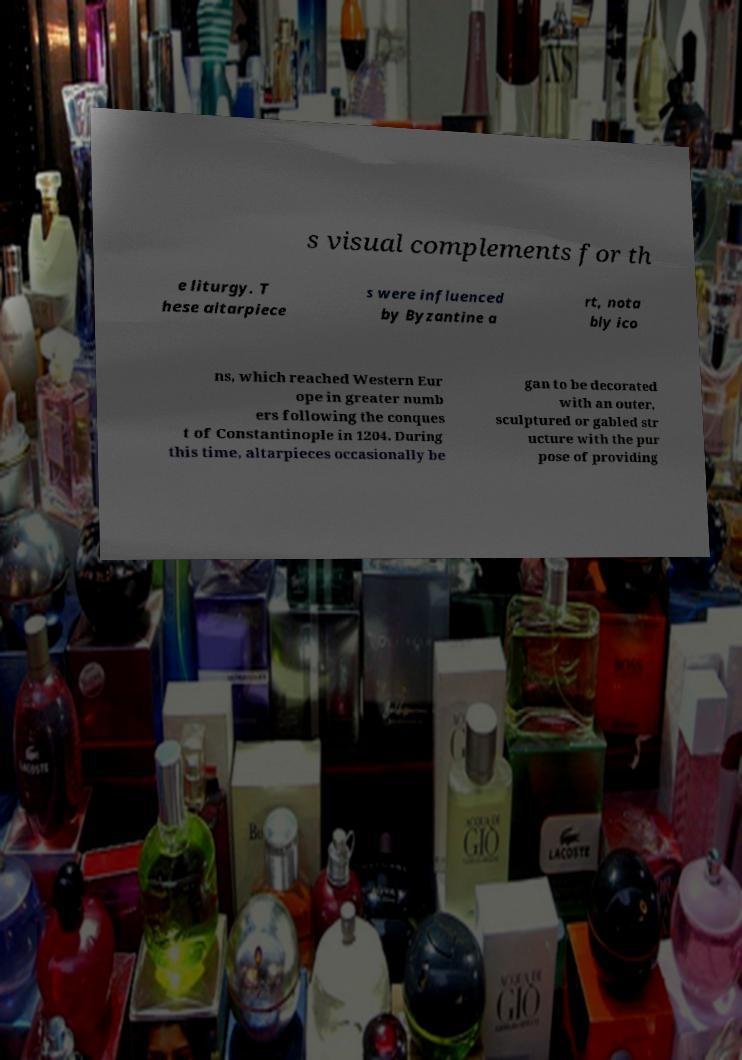What messages or text are displayed in this image? I need them in a readable, typed format. s visual complements for th e liturgy. T hese altarpiece s were influenced by Byzantine a rt, nota bly ico ns, which reached Western Eur ope in greater numb ers following the conques t of Constantinople in 1204. During this time, altarpieces occasionally be gan to be decorated with an outer, sculptured or gabled str ucture with the pur pose of providing 